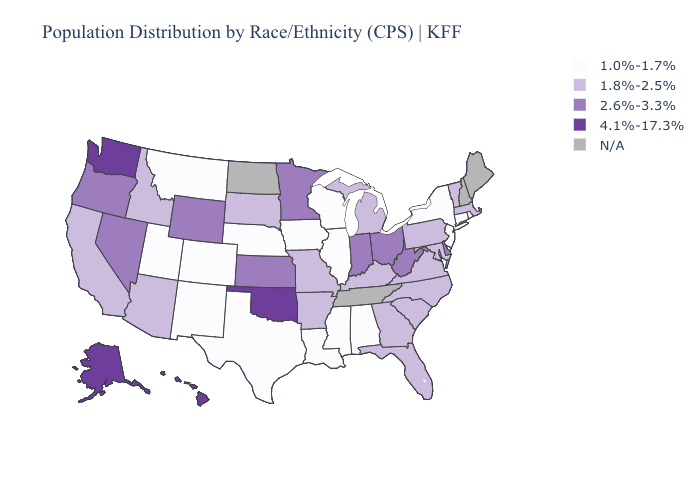Name the states that have a value in the range 4.1%-17.3%?
Answer briefly. Alaska, Hawaii, Oklahoma, Washington. Does the first symbol in the legend represent the smallest category?
Keep it brief. Yes. What is the lowest value in the Northeast?
Write a very short answer. 1.0%-1.7%. Among the states that border Michigan , which have the highest value?
Write a very short answer. Indiana, Ohio. What is the value of Pennsylvania?
Answer briefly. 1.8%-2.5%. Does Pennsylvania have the lowest value in the USA?
Write a very short answer. No. What is the value of Wisconsin?
Answer briefly. 1.0%-1.7%. What is the value of Connecticut?
Short answer required. 1.0%-1.7%. Does the map have missing data?
Concise answer only. Yes. Does New Jersey have the lowest value in the USA?
Keep it brief. Yes. Does Kentucky have the lowest value in the USA?
Short answer required. No. How many symbols are there in the legend?
Quick response, please. 5. Name the states that have a value in the range 2.6%-3.3%?
Concise answer only. Delaware, Indiana, Kansas, Minnesota, Nevada, Ohio, Oregon, West Virginia, Wyoming. Does West Virginia have the lowest value in the South?
Quick response, please. No. 